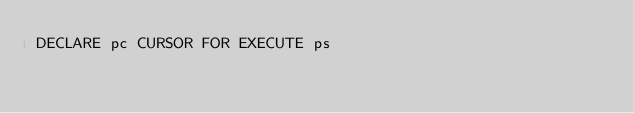<code> <loc_0><loc_0><loc_500><loc_500><_SQL_>DECLARE pc CURSOR FOR EXECUTE ps</code> 